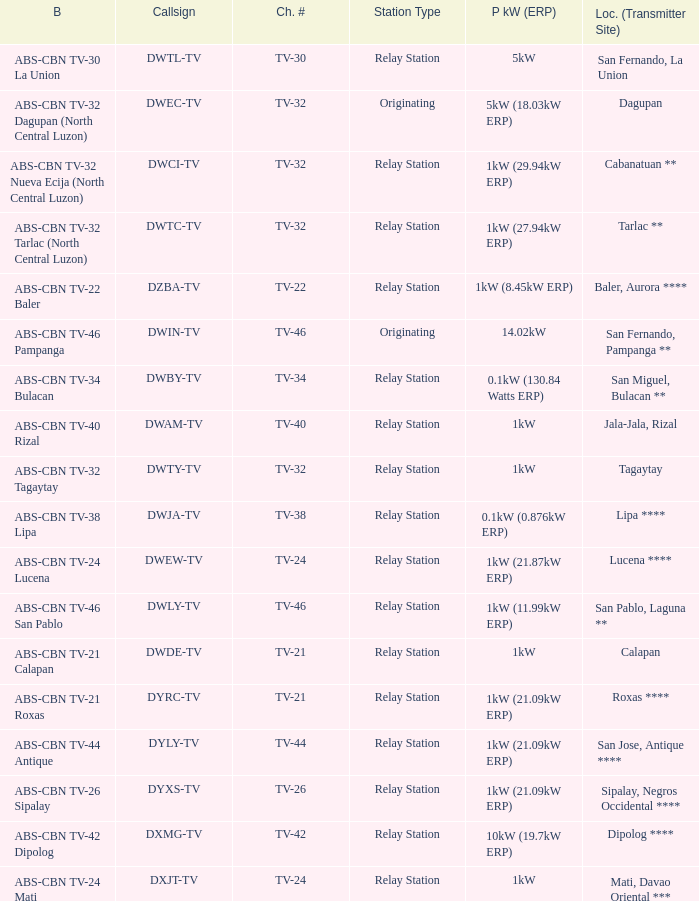What is the station type for the branding ABS-CBN TV-32 Tagaytay? Relay Station. 